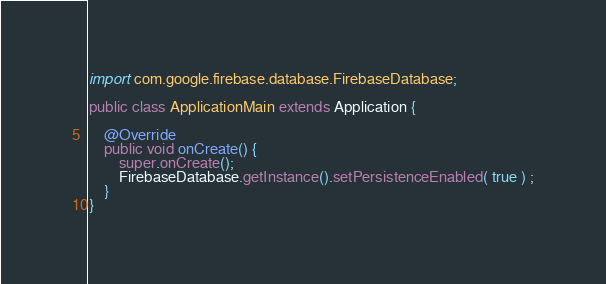Convert code to text. <code><loc_0><loc_0><loc_500><loc_500><_Java_>
import com.google.firebase.database.FirebaseDatabase;

public class ApplicationMain extends Application {

    @Override
    public void onCreate() {
        super.onCreate();
        FirebaseDatabase.getInstance().setPersistenceEnabled( true ) ;
    }
}
</code> 